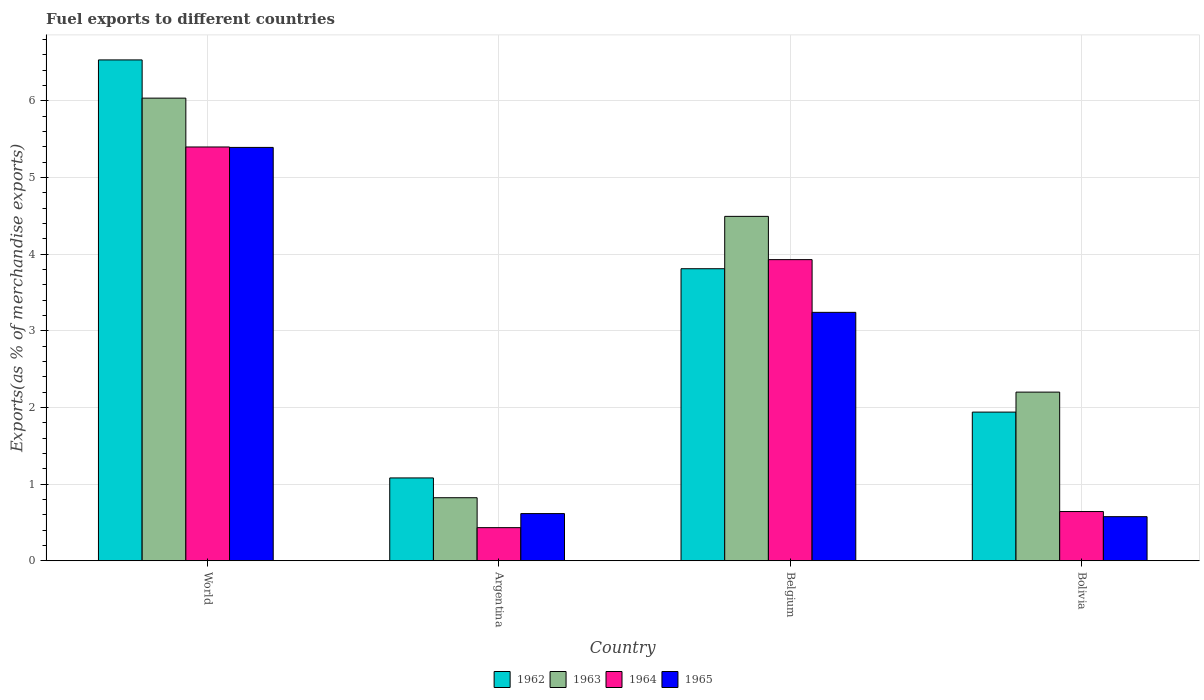What is the percentage of exports to different countries in 1965 in Argentina?
Make the answer very short. 0.62. Across all countries, what is the maximum percentage of exports to different countries in 1964?
Your response must be concise. 5.4. Across all countries, what is the minimum percentage of exports to different countries in 1964?
Your answer should be very brief. 0.43. In which country was the percentage of exports to different countries in 1963 maximum?
Your response must be concise. World. In which country was the percentage of exports to different countries in 1965 minimum?
Provide a short and direct response. Bolivia. What is the total percentage of exports to different countries in 1962 in the graph?
Offer a very short reply. 13.37. What is the difference between the percentage of exports to different countries in 1964 in Belgium and that in Bolivia?
Provide a succinct answer. 3.29. What is the difference between the percentage of exports to different countries in 1965 in Belgium and the percentage of exports to different countries in 1962 in World?
Your response must be concise. -3.29. What is the average percentage of exports to different countries in 1962 per country?
Your response must be concise. 3.34. What is the difference between the percentage of exports to different countries of/in 1963 and percentage of exports to different countries of/in 1962 in World?
Ensure brevity in your answer.  -0.5. In how many countries, is the percentage of exports to different countries in 1965 greater than 4.8 %?
Provide a short and direct response. 1. What is the ratio of the percentage of exports to different countries in 1963 in Argentina to that in World?
Your answer should be very brief. 0.14. Is the percentage of exports to different countries in 1964 in Bolivia less than that in World?
Your answer should be compact. Yes. Is the difference between the percentage of exports to different countries in 1963 in Bolivia and World greater than the difference between the percentage of exports to different countries in 1962 in Bolivia and World?
Provide a short and direct response. Yes. What is the difference between the highest and the second highest percentage of exports to different countries in 1963?
Your response must be concise. -2.29. What is the difference between the highest and the lowest percentage of exports to different countries in 1962?
Keep it short and to the point. 5.45. What does the 4th bar from the left in Argentina represents?
Offer a very short reply. 1965. How many bars are there?
Your answer should be very brief. 16. Are all the bars in the graph horizontal?
Keep it short and to the point. No. How many countries are there in the graph?
Offer a very short reply. 4. What is the difference between two consecutive major ticks on the Y-axis?
Give a very brief answer. 1. Does the graph contain any zero values?
Your answer should be very brief. No. Does the graph contain grids?
Your answer should be compact. Yes. Where does the legend appear in the graph?
Offer a very short reply. Bottom center. How many legend labels are there?
Your response must be concise. 4. What is the title of the graph?
Ensure brevity in your answer.  Fuel exports to different countries. What is the label or title of the X-axis?
Provide a short and direct response. Country. What is the label or title of the Y-axis?
Keep it short and to the point. Exports(as % of merchandise exports). What is the Exports(as % of merchandise exports) of 1962 in World?
Your response must be concise. 6.53. What is the Exports(as % of merchandise exports) in 1963 in World?
Ensure brevity in your answer.  6.04. What is the Exports(as % of merchandise exports) of 1964 in World?
Your answer should be compact. 5.4. What is the Exports(as % of merchandise exports) of 1965 in World?
Your answer should be compact. 5.39. What is the Exports(as % of merchandise exports) in 1962 in Argentina?
Ensure brevity in your answer.  1.08. What is the Exports(as % of merchandise exports) in 1963 in Argentina?
Your answer should be compact. 0.82. What is the Exports(as % of merchandise exports) in 1964 in Argentina?
Provide a short and direct response. 0.43. What is the Exports(as % of merchandise exports) in 1965 in Argentina?
Give a very brief answer. 0.62. What is the Exports(as % of merchandise exports) of 1962 in Belgium?
Offer a very short reply. 3.81. What is the Exports(as % of merchandise exports) of 1963 in Belgium?
Offer a terse response. 4.49. What is the Exports(as % of merchandise exports) in 1964 in Belgium?
Keep it short and to the point. 3.93. What is the Exports(as % of merchandise exports) of 1965 in Belgium?
Provide a short and direct response. 3.24. What is the Exports(as % of merchandise exports) of 1962 in Bolivia?
Provide a succinct answer. 1.94. What is the Exports(as % of merchandise exports) in 1963 in Bolivia?
Provide a short and direct response. 2.2. What is the Exports(as % of merchandise exports) of 1964 in Bolivia?
Make the answer very short. 0.64. What is the Exports(as % of merchandise exports) of 1965 in Bolivia?
Give a very brief answer. 0.58. Across all countries, what is the maximum Exports(as % of merchandise exports) of 1962?
Ensure brevity in your answer.  6.53. Across all countries, what is the maximum Exports(as % of merchandise exports) in 1963?
Provide a short and direct response. 6.04. Across all countries, what is the maximum Exports(as % of merchandise exports) of 1964?
Make the answer very short. 5.4. Across all countries, what is the maximum Exports(as % of merchandise exports) in 1965?
Offer a terse response. 5.39. Across all countries, what is the minimum Exports(as % of merchandise exports) of 1962?
Provide a succinct answer. 1.08. Across all countries, what is the minimum Exports(as % of merchandise exports) of 1963?
Make the answer very short. 0.82. Across all countries, what is the minimum Exports(as % of merchandise exports) of 1964?
Your response must be concise. 0.43. Across all countries, what is the minimum Exports(as % of merchandise exports) of 1965?
Make the answer very short. 0.58. What is the total Exports(as % of merchandise exports) in 1962 in the graph?
Provide a short and direct response. 13.37. What is the total Exports(as % of merchandise exports) in 1963 in the graph?
Give a very brief answer. 13.55. What is the total Exports(as % of merchandise exports) of 1964 in the graph?
Provide a short and direct response. 10.4. What is the total Exports(as % of merchandise exports) in 1965 in the graph?
Provide a succinct answer. 9.83. What is the difference between the Exports(as % of merchandise exports) of 1962 in World and that in Argentina?
Offer a very short reply. 5.45. What is the difference between the Exports(as % of merchandise exports) in 1963 in World and that in Argentina?
Offer a terse response. 5.21. What is the difference between the Exports(as % of merchandise exports) in 1964 in World and that in Argentina?
Your answer should be very brief. 4.97. What is the difference between the Exports(as % of merchandise exports) in 1965 in World and that in Argentina?
Make the answer very short. 4.78. What is the difference between the Exports(as % of merchandise exports) in 1962 in World and that in Belgium?
Your response must be concise. 2.72. What is the difference between the Exports(as % of merchandise exports) in 1963 in World and that in Belgium?
Provide a succinct answer. 1.54. What is the difference between the Exports(as % of merchandise exports) of 1964 in World and that in Belgium?
Give a very brief answer. 1.47. What is the difference between the Exports(as % of merchandise exports) of 1965 in World and that in Belgium?
Ensure brevity in your answer.  2.15. What is the difference between the Exports(as % of merchandise exports) of 1962 in World and that in Bolivia?
Offer a very short reply. 4.59. What is the difference between the Exports(as % of merchandise exports) of 1963 in World and that in Bolivia?
Ensure brevity in your answer.  3.84. What is the difference between the Exports(as % of merchandise exports) of 1964 in World and that in Bolivia?
Your answer should be very brief. 4.76. What is the difference between the Exports(as % of merchandise exports) in 1965 in World and that in Bolivia?
Provide a short and direct response. 4.82. What is the difference between the Exports(as % of merchandise exports) in 1962 in Argentina and that in Belgium?
Your answer should be very brief. -2.73. What is the difference between the Exports(as % of merchandise exports) of 1963 in Argentina and that in Belgium?
Ensure brevity in your answer.  -3.67. What is the difference between the Exports(as % of merchandise exports) of 1964 in Argentina and that in Belgium?
Your answer should be compact. -3.5. What is the difference between the Exports(as % of merchandise exports) of 1965 in Argentina and that in Belgium?
Keep it short and to the point. -2.63. What is the difference between the Exports(as % of merchandise exports) in 1962 in Argentina and that in Bolivia?
Make the answer very short. -0.86. What is the difference between the Exports(as % of merchandise exports) of 1963 in Argentina and that in Bolivia?
Provide a succinct answer. -1.38. What is the difference between the Exports(as % of merchandise exports) of 1964 in Argentina and that in Bolivia?
Provide a succinct answer. -0.21. What is the difference between the Exports(as % of merchandise exports) in 1965 in Argentina and that in Bolivia?
Make the answer very short. 0.04. What is the difference between the Exports(as % of merchandise exports) in 1962 in Belgium and that in Bolivia?
Give a very brief answer. 1.87. What is the difference between the Exports(as % of merchandise exports) in 1963 in Belgium and that in Bolivia?
Your answer should be very brief. 2.29. What is the difference between the Exports(as % of merchandise exports) in 1964 in Belgium and that in Bolivia?
Ensure brevity in your answer.  3.29. What is the difference between the Exports(as % of merchandise exports) of 1965 in Belgium and that in Bolivia?
Offer a very short reply. 2.67. What is the difference between the Exports(as % of merchandise exports) of 1962 in World and the Exports(as % of merchandise exports) of 1963 in Argentina?
Offer a terse response. 5.71. What is the difference between the Exports(as % of merchandise exports) of 1962 in World and the Exports(as % of merchandise exports) of 1964 in Argentina?
Your response must be concise. 6.1. What is the difference between the Exports(as % of merchandise exports) of 1962 in World and the Exports(as % of merchandise exports) of 1965 in Argentina?
Give a very brief answer. 5.92. What is the difference between the Exports(as % of merchandise exports) in 1963 in World and the Exports(as % of merchandise exports) in 1964 in Argentina?
Your answer should be very brief. 5.6. What is the difference between the Exports(as % of merchandise exports) of 1963 in World and the Exports(as % of merchandise exports) of 1965 in Argentina?
Provide a succinct answer. 5.42. What is the difference between the Exports(as % of merchandise exports) of 1964 in World and the Exports(as % of merchandise exports) of 1965 in Argentina?
Offer a very short reply. 4.78. What is the difference between the Exports(as % of merchandise exports) of 1962 in World and the Exports(as % of merchandise exports) of 1963 in Belgium?
Make the answer very short. 2.04. What is the difference between the Exports(as % of merchandise exports) in 1962 in World and the Exports(as % of merchandise exports) in 1964 in Belgium?
Offer a terse response. 2.61. What is the difference between the Exports(as % of merchandise exports) of 1962 in World and the Exports(as % of merchandise exports) of 1965 in Belgium?
Your response must be concise. 3.29. What is the difference between the Exports(as % of merchandise exports) of 1963 in World and the Exports(as % of merchandise exports) of 1964 in Belgium?
Give a very brief answer. 2.11. What is the difference between the Exports(as % of merchandise exports) of 1963 in World and the Exports(as % of merchandise exports) of 1965 in Belgium?
Offer a terse response. 2.79. What is the difference between the Exports(as % of merchandise exports) of 1964 in World and the Exports(as % of merchandise exports) of 1965 in Belgium?
Provide a succinct answer. 2.16. What is the difference between the Exports(as % of merchandise exports) of 1962 in World and the Exports(as % of merchandise exports) of 1963 in Bolivia?
Offer a terse response. 4.33. What is the difference between the Exports(as % of merchandise exports) in 1962 in World and the Exports(as % of merchandise exports) in 1964 in Bolivia?
Ensure brevity in your answer.  5.89. What is the difference between the Exports(as % of merchandise exports) of 1962 in World and the Exports(as % of merchandise exports) of 1965 in Bolivia?
Provide a succinct answer. 5.96. What is the difference between the Exports(as % of merchandise exports) of 1963 in World and the Exports(as % of merchandise exports) of 1964 in Bolivia?
Give a very brief answer. 5.39. What is the difference between the Exports(as % of merchandise exports) in 1963 in World and the Exports(as % of merchandise exports) in 1965 in Bolivia?
Offer a very short reply. 5.46. What is the difference between the Exports(as % of merchandise exports) in 1964 in World and the Exports(as % of merchandise exports) in 1965 in Bolivia?
Offer a terse response. 4.82. What is the difference between the Exports(as % of merchandise exports) of 1962 in Argentina and the Exports(as % of merchandise exports) of 1963 in Belgium?
Offer a very short reply. -3.41. What is the difference between the Exports(as % of merchandise exports) in 1962 in Argentina and the Exports(as % of merchandise exports) in 1964 in Belgium?
Make the answer very short. -2.85. What is the difference between the Exports(as % of merchandise exports) in 1962 in Argentina and the Exports(as % of merchandise exports) in 1965 in Belgium?
Your response must be concise. -2.16. What is the difference between the Exports(as % of merchandise exports) in 1963 in Argentina and the Exports(as % of merchandise exports) in 1964 in Belgium?
Your response must be concise. -3.11. What is the difference between the Exports(as % of merchandise exports) of 1963 in Argentina and the Exports(as % of merchandise exports) of 1965 in Belgium?
Keep it short and to the point. -2.42. What is the difference between the Exports(as % of merchandise exports) in 1964 in Argentina and the Exports(as % of merchandise exports) in 1965 in Belgium?
Ensure brevity in your answer.  -2.81. What is the difference between the Exports(as % of merchandise exports) in 1962 in Argentina and the Exports(as % of merchandise exports) in 1963 in Bolivia?
Ensure brevity in your answer.  -1.12. What is the difference between the Exports(as % of merchandise exports) of 1962 in Argentina and the Exports(as % of merchandise exports) of 1964 in Bolivia?
Your answer should be very brief. 0.44. What is the difference between the Exports(as % of merchandise exports) of 1962 in Argentina and the Exports(as % of merchandise exports) of 1965 in Bolivia?
Offer a terse response. 0.51. What is the difference between the Exports(as % of merchandise exports) of 1963 in Argentina and the Exports(as % of merchandise exports) of 1964 in Bolivia?
Provide a succinct answer. 0.18. What is the difference between the Exports(as % of merchandise exports) of 1963 in Argentina and the Exports(as % of merchandise exports) of 1965 in Bolivia?
Your answer should be very brief. 0.25. What is the difference between the Exports(as % of merchandise exports) of 1964 in Argentina and the Exports(as % of merchandise exports) of 1965 in Bolivia?
Provide a short and direct response. -0.14. What is the difference between the Exports(as % of merchandise exports) in 1962 in Belgium and the Exports(as % of merchandise exports) in 1963 in Bolivia?
Offer a very short reply. 1.61. What is the difference between the Exports(as % of merchandise exports) in 1962 in Belgium and the Exports(as % of merchandise exports) in 1964 in Bolivia?
Provide a succinct answer. 3.17. What is the difference between the Exports(as % of merchandise exports) in 1962 in Belgium and the Exports(as % of merchandise exports) in 1965 in Bolivia?
Offer a terse response. 3.23. What is the difference between the Exports(as % of merchandise exports) of 1963 in Belgium and the Exports(as % of merchandise exports) of 1964 in Bolivia?
Provide a succinct answer. 3.85. What is the difference between the Exports(as % of merchandise exports) in 1963 in Belgium and the Exports(as % of merchandise exports) in 1965 in Bolivia?
Provide a short and direct response. 3.92. What is the difference between the Exports(as % of merchandise exports) in 1964 in Belgium and the Exports(as % of merchandise exports) in 1965 in Bolivia?
Give a very brief answer. 3.35. What is the average Exports(as % of merchandise exports) of 1962 per country?
Make the answer very short. 3.34. What is the average Exports(as % of merchandise exports) of 1963 per country?
Provide a succinct answer. 3.39. What is the average Exports(as % of merchandise exports) in 1964 per country?
Your answer should be compact. 2.6. What is the average Exports(as % of merchandise exports) of 1965 per country?
Give a very brief answer. 2.46. What is the difference between the Exports(as % of merchandise exports) in 1962 and Exports(as % of merchandise exports) in 1963 in World?
Your answer should be very brief. 0.5. What is the difference between the Exports(as % of merchandise exports) in 1962 and Exports(as % of merchandise exports) in 1964 in World?
Your response must be concise. 1.14. What is the difference between the Exports(as % of merchandise exports) of 1962 and Exports(as % of merchandise exports) of 1965 in World?
Keep it short and to the point. 1.14. What is the difference between the Exports(as % of merchandise exports) of 1963 and Exports(as % of merchandise exports) of 1964 in World?
Ensure brevity in your answer.  0.64. What is the difference between the Exports(as % of merchandise exports) of 1963 and Exports(as % of merchandise exports) of 1965 in World?
Your response must be concise. 0.64. What is the difference between the Exports(as % of merchandise exports) of 1964 and Exports(as % of merchandise exports) of 1965 in World?
Your answer should be very brief. 0.01. What is the difference between the Exports(as % of merchandise exports) of 1962 and Exports(as % of merchandise exports) of 1963 in Argentina?
Provide a short and direct response. 0.26. What is the difference between the Exports(as % of merchandise exports) of 1962 and Exports(as % of merchandise exports) of 1964 in Argentina?
Keep it short and to the point. 0.65. What is the difference between the Exports(as % of merchandise exports) of 1962 and Exports(as % of merchandise exports) of 1965 in Argentina?
Make the answer very short. 0.47. What is the difference between the Exports(as % of merchandise exports) of 1963 and Exports(as % of merchandise exports) of 1964 in Argentina?
Offer a terse response. 0.39. What is the difference between the Exports(as % of merchandise exports) of 1963 and Exports(as % of merchandise exports) of 1965 in Argentina?
Your answer should be compact. 0.21. What is the difference between the Exports(as % of merchandise exports) in 1964 and Exports(as % of merchandise exports) in 1965 in Argentina?
Ensure brevity in your answer.  -0.18. What is the difference between the Exports(as % of merchandise exports) in 1962 and Exports(as % of merchandise exports) in 1963 in Belgium?
Provide a short and direct response. -0.68. What is the difference between the Exports(as % of merchandise exports) of 1962 and Exports(as % of merchandise exports) of 1964 in Belgium?
Your response must be concise. -0.12. What is the difference between the Exports(as % of merchandise exports) of 1962 and Exports(as % of merchandise exports) of 1965 in Belgium?
Provide a succinct answer. 0.57. What is the difference between the Exports(as % of merchandise exports) in 1963 and Exports(as % of merchandise exports) in 1964 in Belgium?
Your answer should be compact. 0.56. What is the difference between the Exports(as % of merchandise exports) of 1963 and Exports(as % of merchandise exports) of 1965 in Belgium?
Provide a short and direct response. 1.25. What is the difference between the Exports(as % of merchandise exports) of 1964 and Exports(as % of merchandise exports) of 1965 in Belgium?
Keep it short and to the point. 0.69. What is the difference between the Exports(as % of merchandise exports) of 1962 and Exports(as % of merchandise exports) of 1963 in Bolivia?
Ensure brevity in your answer.  -0.26. What is the difference between the Exports(as % of merchandise exports) in 1962 and Exports(as % of merchandise exports) in 1964 in Bolivia?
Offer a terse response. 1.3. What is the difference between the Exports(as % of merchandise exports) in 1962 and Exports(as % of merchandise exports) in 1965 in Bolivia?
Ensure brevity in your answer.  1.36. What is the difference between the Exports(as % of merchandise exports) in 1963 and Exports(as % of merchandise exports) in 1964 in Bolivia?
Provide a short and direct response. 1.56. What is the difference between the Exports(as % of merchandise exports) of 1963 and Exports(as % of merchandise exports) of 1965 in Bolivia?
Your response must be concise. 1.62. What is the difference between the Exports(as % of merchandise exports) in 1964 and Exports(as % of merchandise exports) in 1965 in Bolivia?
Give a very brief answer. 0.07. What is the ratio of the Exports(as % of merchandise exports) of 1962 in World to that in Argentina?
Ensure brevity in your answer.  6.05. What is the ratio of the Exports(as % of merchandise exports) in 1963 in World to that in Argentina?
Offer a terse response. 7.34. What is the ratio of the Exports(as % of merchandise exports) of 1964 in World to that in Argentina?
Provide a short and direct response. 12.49. What is the ratio of the Exports(as % of merchandise exports) of 1965 in World to that in Argentina?
Give a very brief answer. 8.76. What is the ratio of the Exports(as % of merchandise exports) in 1962 in World to that in Belgium?
Offer a terse response. 1.72. What is the ratio of the Exports(as % of merchandise exports) in 1963 in World to that in Belgium?
Offer a very short reply. 1.34. What is the ratio of the Exports(as % of merchandise exports) in 1964 in World to that in Belgium?
Your answer should be very brief. 1.37. What is the ratio of the Exports(as % of merchandise exports) in 1965 in World to that in Belgium?
Your answer should be very brief. 1.66. What is the ratio of the Exports(as % of merchandise exports) in 1962 in World to that in Bolivia?
Your response must be concise. 3.37. What is the ratio of the Exports(as % of merchandise exports) of 1963 in World to that in Bolivia?
Give a very brief answer. 2.74. What is the ratio of the Exports(as % of merchandise exports) of 1964 in World to that in Bolivia?
Offer a terse response. 8.4. What is the ratio of the Exports(as % of merchandise exports) in 1965 in World to that in Bolivia?
Make the answer very short. 9.37. What is the ratio of the Exports(as % of merchandise exports) of 1962 in Argentina to that in Belgium?
Offer a terse response. 0.28. What is the ratio of the Exports(as % of merchandise exports) of 1963 in Argentina to that in Belgium?
Make the answer very short. 0.18. What is the ratio of the Exports(as % of merchandise exports) of 1964 in Argentina to that in Belgium?
Keep it short and to the point. 0.11. What is the ratio of the Exports(as % of merchandise exports) of 1965 in Argentina to that in Belgium?
Make the answer very short. 0.19. What is the ratio of the Exports(as % of merchandise exports) in 1962 in Argentina to that in Bolivia?
Offer a very short reply. 0.56. What is the ratio of the Exports(as % of merchandise exports) in 1963 in Argentina to that in Bolivia?
Your response must be concise. 0.37. What is the ratio of the Exports(as % of merchandise exports) of 1964 in Argentina to that in Bolivia?
Offer a very short reply. 0.67. What is the ratio of the Exports(as % of merchandise exports) in 1965 in Argentina to that in Bolivia?
Keep it short and to the point. 1.07. What is the ratio of the Exports(as % of merchandise exports) in 1962 in Belgium to that in Bolivia?
Provide a succinct answer. 1.96. What is the ratio of the Exports(as % of merchandise exports) of 1963 in Belgium to that in Bolivia?
Provide a short and direct response. 2.04. What is the ratio of the Exports(as % of merchandise exports) of 1964 in Belgium to that in Bolivia?
Keep it short and to the point. 6.12. What is the ratio of the Exports(as % of merchandise exports) of 1965 in Belgium to that in Bolivia?
Provide a succinct answer. 5.63. What is the difference between the highest and the second highest Exports(as % of merchandise exports) in 1962?
Make the answer very short. 2.72. What is the difference between the highest and the second highest Exports(as % of merchandise exports) in 1963?
Give a very brief answer. 1.54. What is the difference between the highest and the second highest Exports(as % of merchandise exports) of 1964?
Provide a short and direct response. 1.47. What is the difference between the highest and the second highest Exports(as % of merchandise exports) of 1965?
Your answer should be very brief. 2.15. What is the difference between the highest and the lowest Exports(as % of merchandise exports) in 1962?
Offer a very short reply. 5.45. What is the difference between the highest and the lowest Exports(as % of merchandise exports) in 1963?
Offer a very short reply. 5.21. What is the difference between the highest and the lowest Exports(as % of merchandise exports) in 1964?
Your answer should be very brief. 4.97. What is the difference between the highest and the lowest Exports(as % of merchandise exports) of 1965?
Your response must be concise. 4.82. 